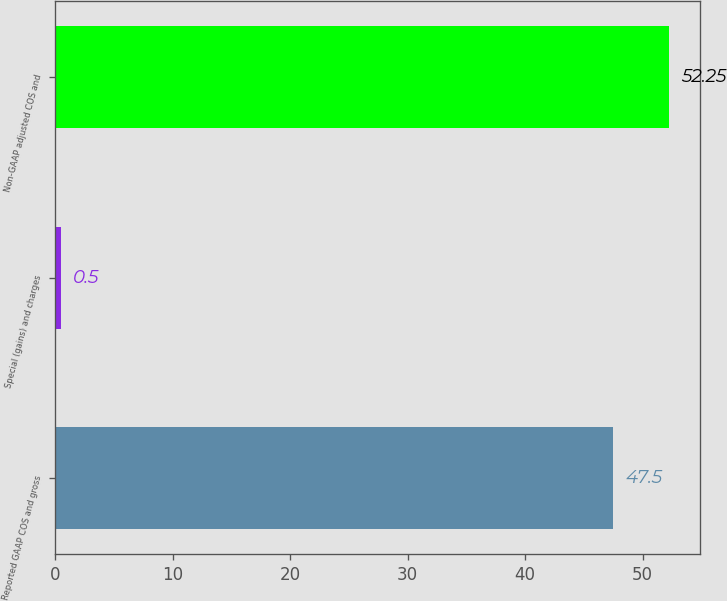<chart> <loc_0><loc_0><loc_500><loc_500><bar_chart><fcel>Reported GAAP COS and gross<fcel>Special (gains) and charges<fcel>Non-GAAP adjusted COS and<nl><fcel>47.5<fcel>0.5<fcel>52.25<nl></chart> 